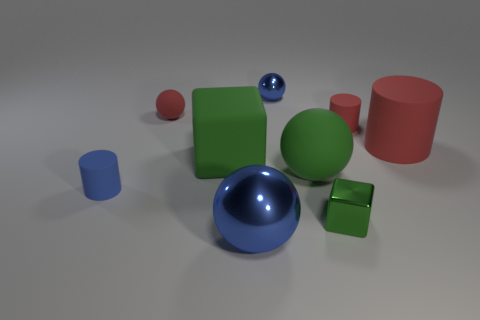What color is the tiny shiny block?
Provide a short and direct response. Green. How many things are either green metal blocks or large blue balls?
Your answer should be compact. 2. Are there fewer small green metallic blocks that are right of the small green object than cyan rubber balls?
Offer a very short reply. No. Is the number of blue spheres in front of the blue cylinder greater than the number of big things that are to the left of the small metal block?
Offer a very short reply. No. There is a tiny blue thing behind the small red matte cylinder; what material is it?
Ensure brevity in your answer.  Metal. Do the green matte block and the green ball have the same size?
Provide a short and direct response. Yes. How many other objects are there of the same size as the blue matte cylinder?
Give a very brief answer. 4. Does the large block have the same color as the small metal cube?
Offer a terse response. Yes. The blue object that is to the left of the blue metal ball that is in front of the large green rubber thing that is on the left side of the big green sphere is what shape?
Make the answer very short. Cylinder. How many things are either metallic things that are behind the small blue cylinder or blue balls behind the tiny rubber ball?
Give a very brief answer. 1. 